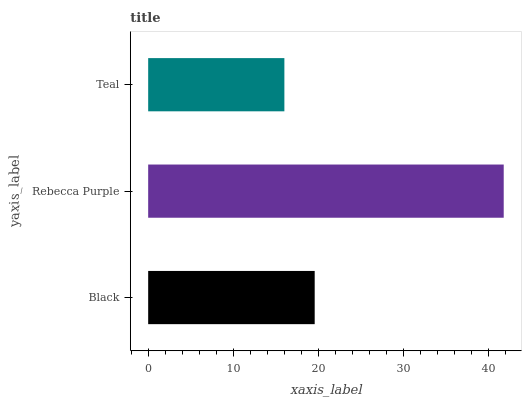Is Teal the minimum?
Answer yes or no. Yes. Is Rebecca Purple the maximum?
Answer yes or no. Yes. Is Rebecca Purple the minimum?
Answer yes or no. No. Is Teal the maximum?
Answer yes or no. No. Is Rebecca Purple greater than Teal?
Answer yes or no. Yes. Is Teal less than Rebecca Purple?
Answer yes or no. Yes. Is Teal greater than Rebecca Purple?
Answer yes or no. No. Is Rebecca Purple less than Teal?
Answer yes or no. No. Is Black the high median?
Answer yes or no. Yes. Is Black the low median?
Answer yes or no. Yes. Is Rebecca Purple the high median?
Answer yes or no. No. Is Teal the low median?
Answer yes or no. No. 